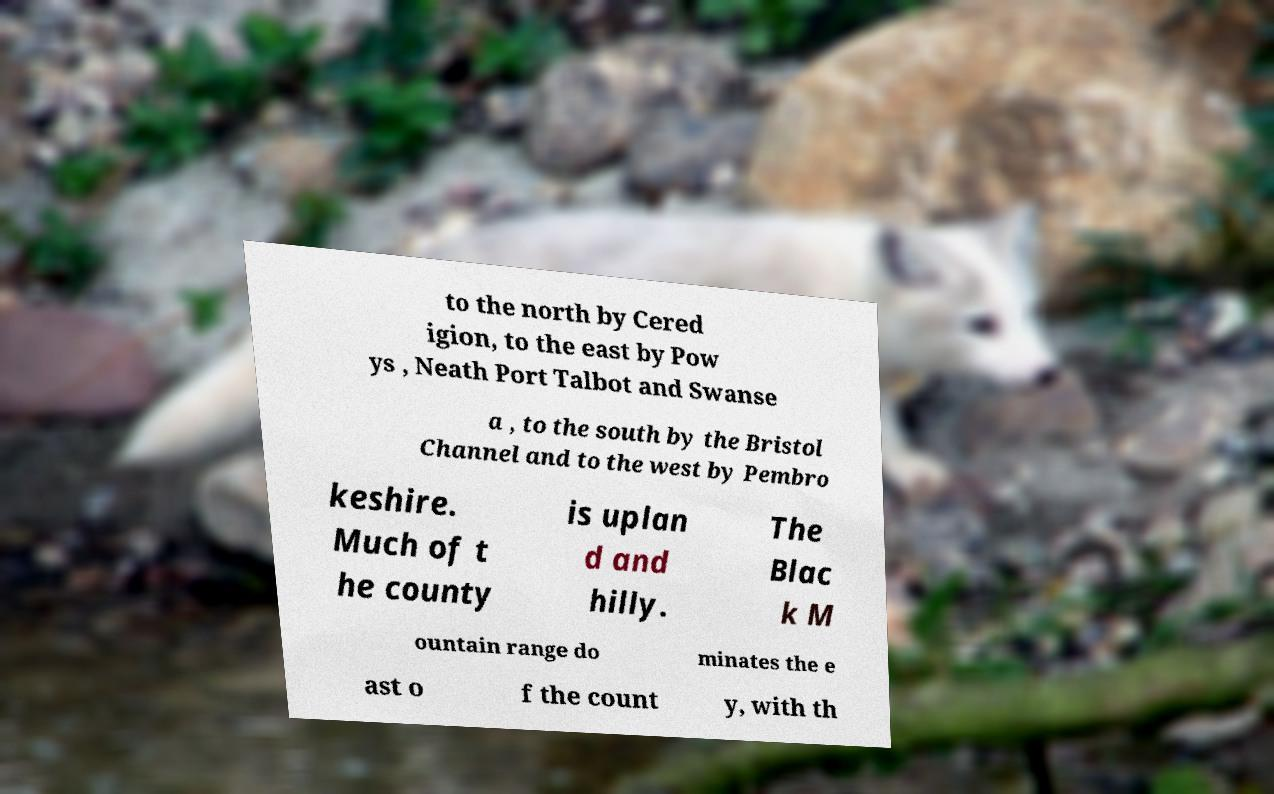What messages or text are displayed in this image? I need them in a readable, typed format. to the north by Cered igion, to the east by Pow ys , Neath Port Talbot and Swanse a , to the south by the Bristol Channel and to the west by Pembro keshire. Much of t he county is uplan d and hilly. The Blac k M ountain range do minates the e ast o f the count y, with th 